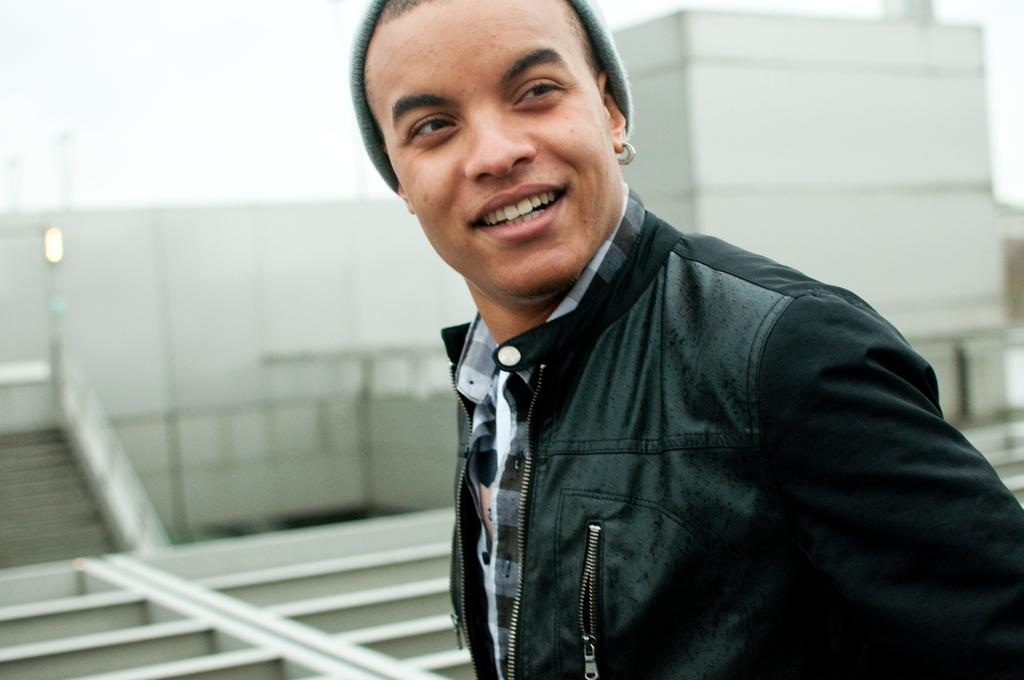What type of structure is visible in the image? There are stairs in the image. Who is present in the image? A man is present in the image. What is the man wearing? The man is wearing a black jacket. What is the man's facial expression? The man is smiling. How does the man increase his muscle mass in the image? There is no indication in the image that the man is attempting to increase his muscle mass. 